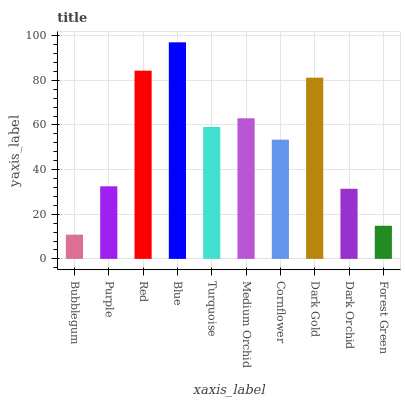Is Bubblegum the minimum?
Answer yes or no. Yes. Is Blue the maximum?
Answer yes or no. Yes. Is Purple the minimum?
Answer yes or no. No. Is Purple the maximum?
Answer yes or no. No. Is Purple greater than Bubblegum?
Answer yes or no. Yes. Is Bubblegum less than Purple?
Answer yes or no. Yes. Is Bubblegum greater than Purple?
Answer yes or no. No. Is Purple less than Bubblegum?
Answer yes or no. No. Is Turquoise the high median?
Answer yes or no. Yes. Is Cornflower the low median?
Answer yes or no. Yes. Is Purple the high median?
Answer yes or no. No. Is Dark Gold the low median?
Answer yes or no. No. 